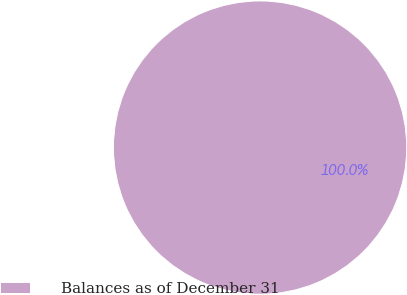Convert chart. <chart><loc_0><loc_0><loc_500><loc_500><pie_chart><fcel>Balances as of December 31<nl><fcel>100.0%<nl></chart> 